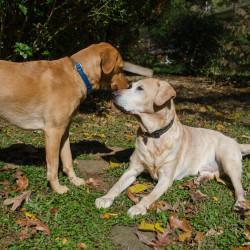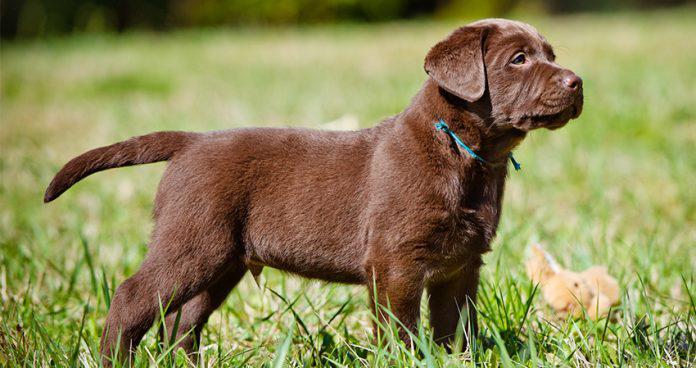The first image is the image on the left, the second image is the image on the right. Assess this claim about the two images: "The combined images include two standing dogs, with at least one of them wearing a collar but no pack.". Correct or not? Answer yes or no. Yes. The first image is the image on the left, the second image is the image on the right. Examine the images to the left and right. Is the description "The left image contains exactly two dogs." accurate? Answer yes or no. Yes. 